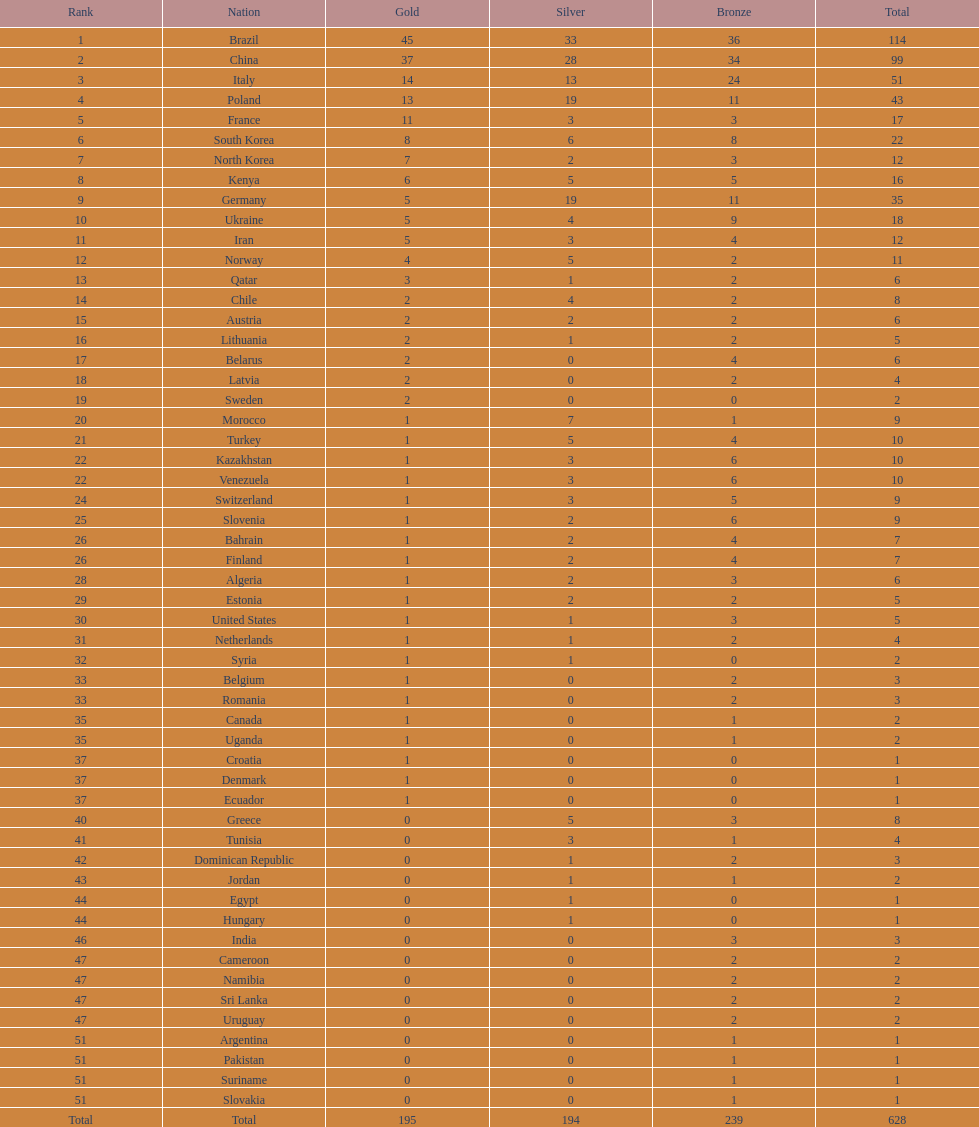Was the total medal count for italy or norway 51? Italy. 